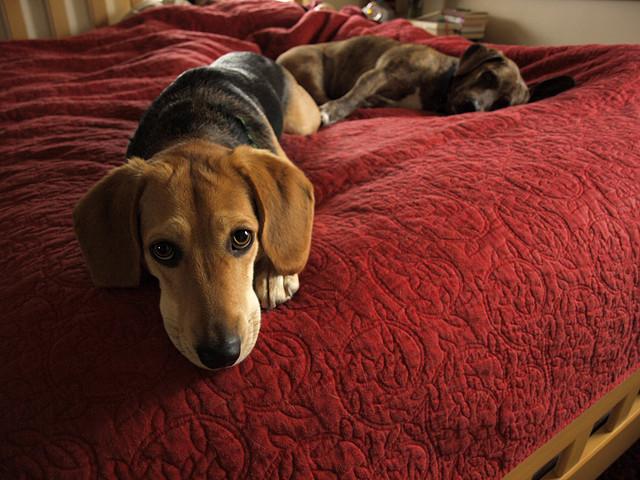Are the dogs the same kind?
Give a very brief answer. No. What color is the bed?
Quick response, please. Red. How many of the dogs are awake?
Write a very short answer. 1. How many dogs are on this bed?
Keep it brief. 2. What breed is the dog?
Answer briefly. Beagle. What are the dogs laying on?
Quick response, please. Bed. What is the dog resting its head on?
Concise answer only. Bed. 